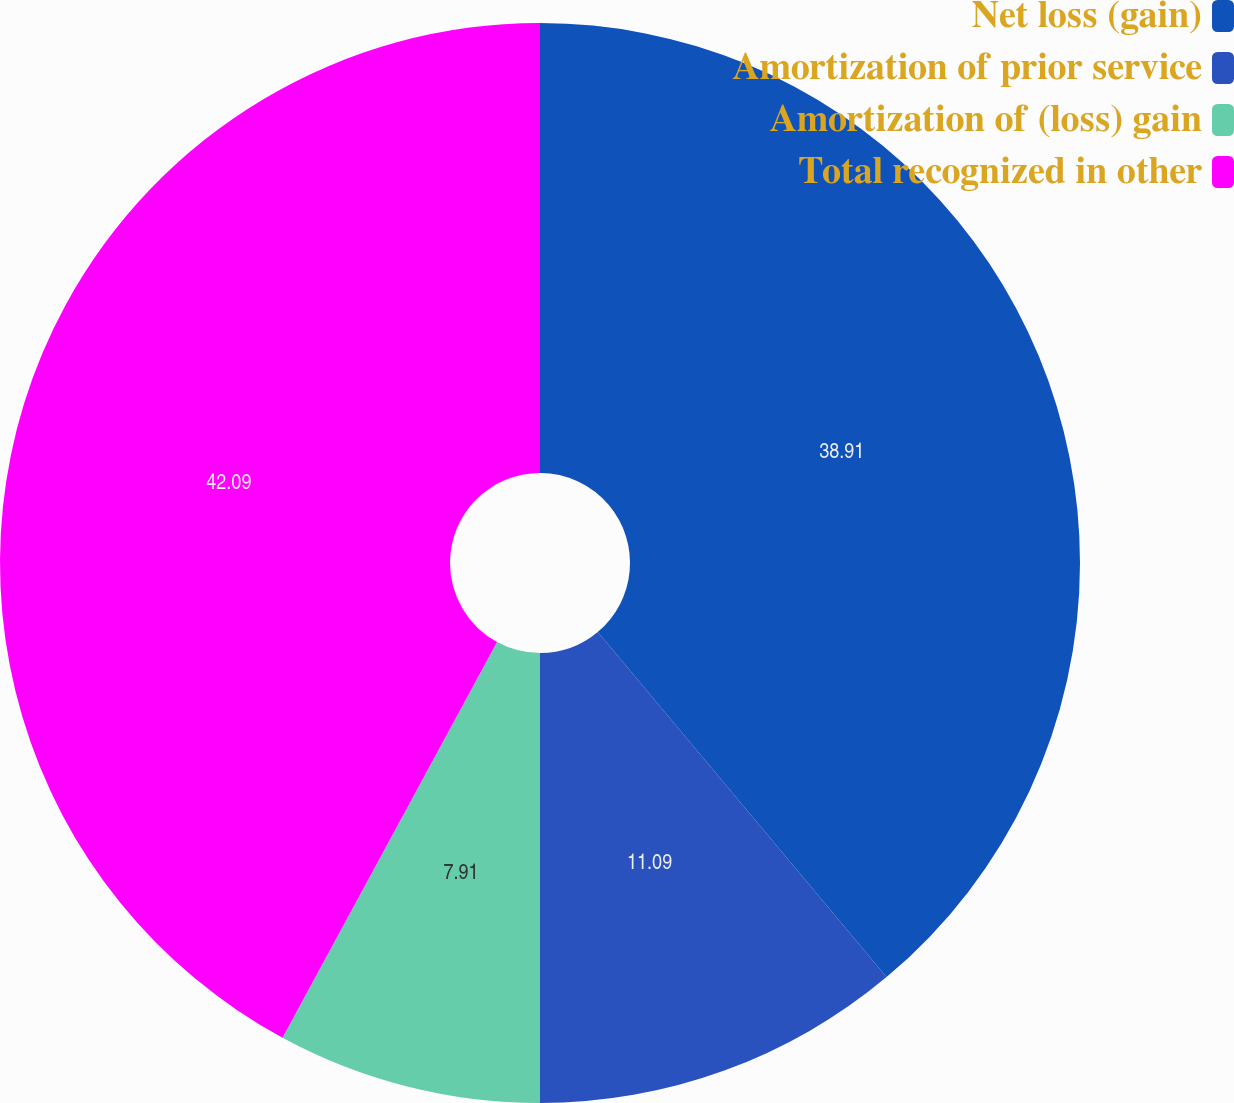Convert chart to OTSL. <chart><loc_0><loc_0><loc_500><loc_500><pie_chart><fcel>Net loss (gain)<fcel>Amortization of prior service<fcel>Amortization of (loss) gain<fcel>Total recognized in other<nl><fcel>38.91%<fcel>11.09%<fcel>7.91%<fcel>42.09%<nl></chart> 